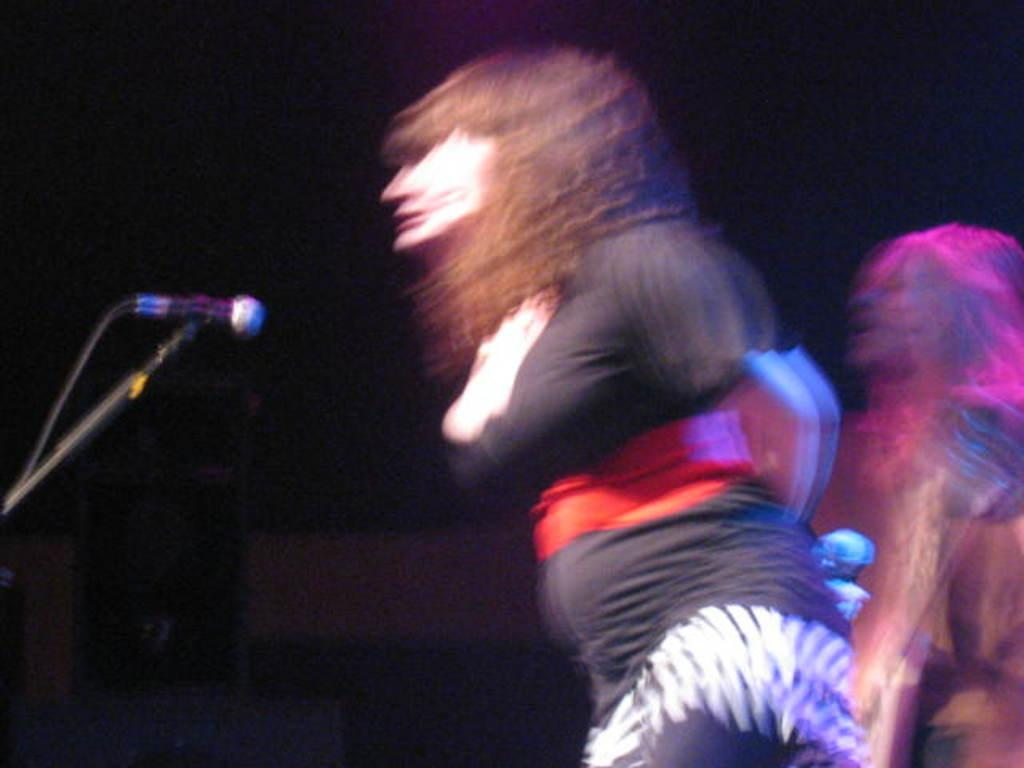How many people are present in the image? There are two people in the image. What objects can be seen in the image that are related to the people? There are microphones in the image. Can you describe the background of the image? The background of the image is dark. What type of drug can be seen in the image? There is no drug present in the image. What type of rake is being used by one of the people in the image? There is no rake present in the image. 